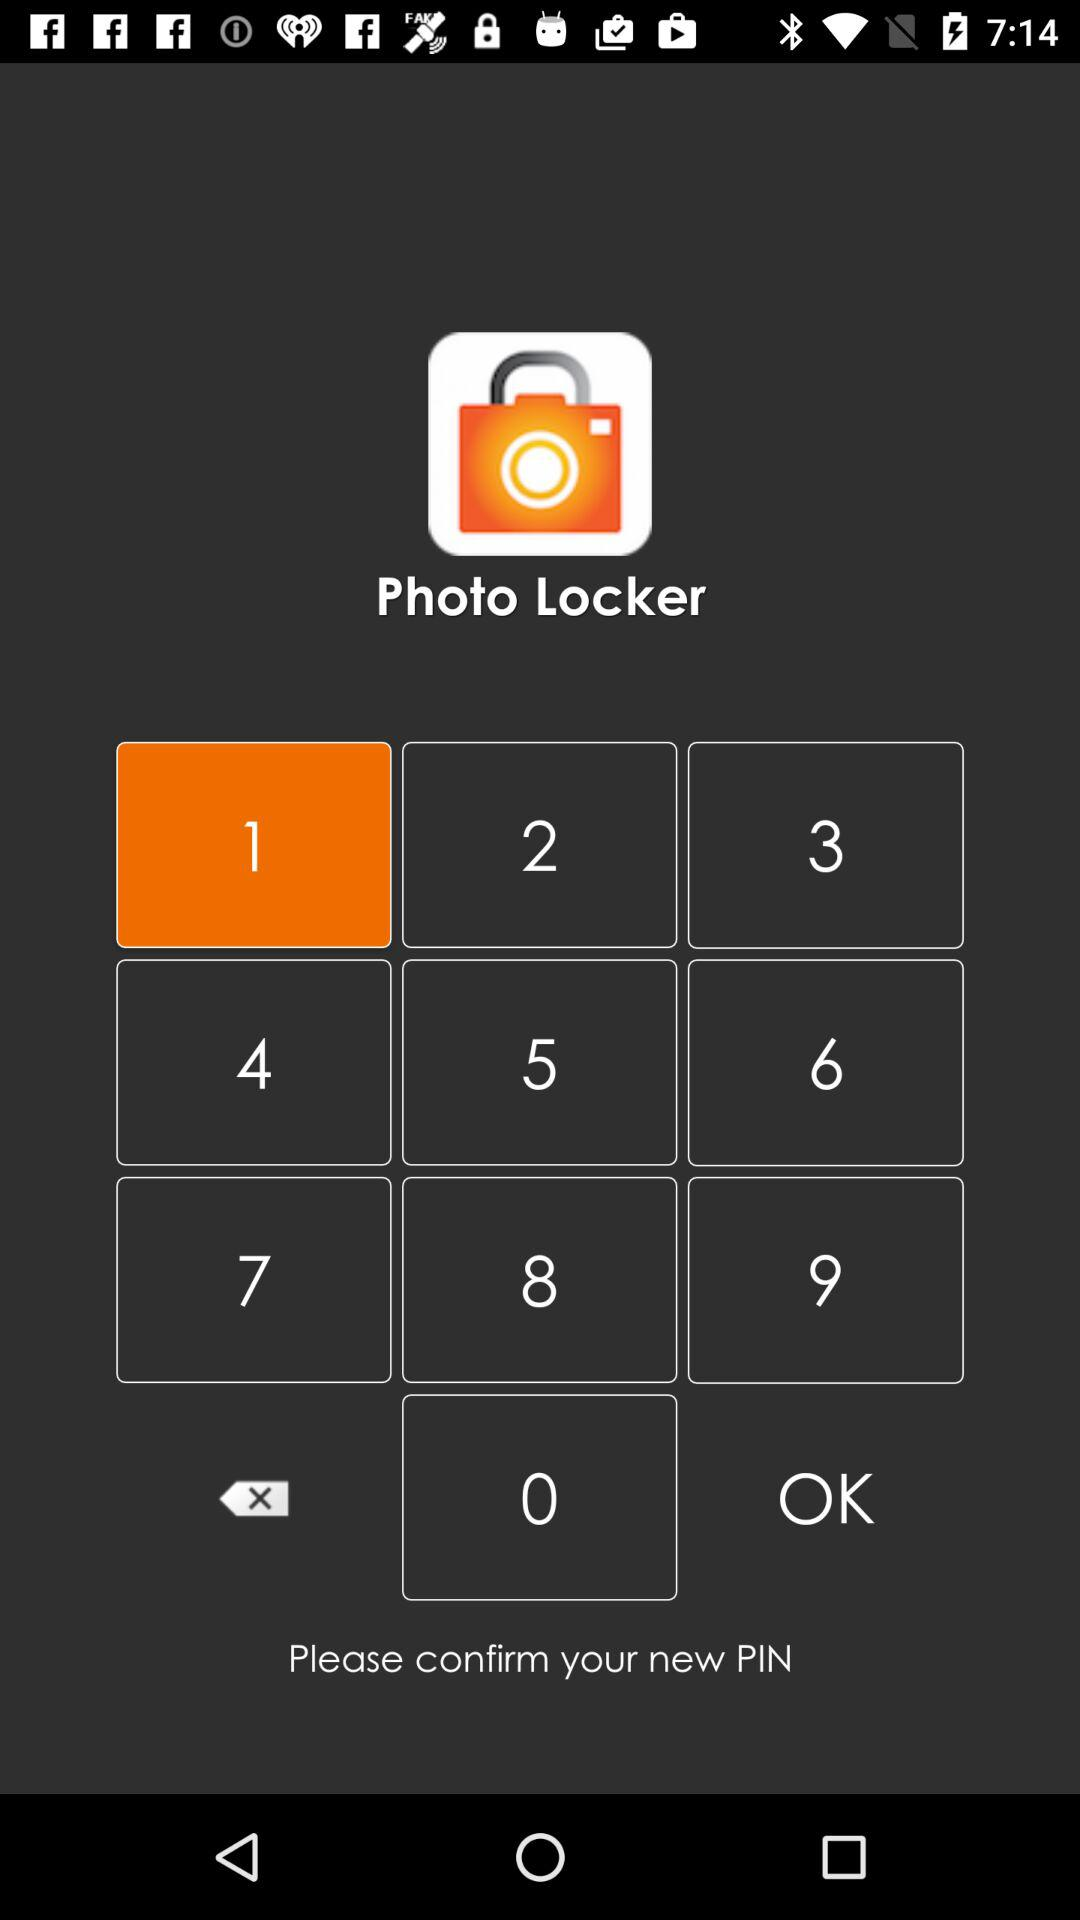What is the app name? The app name is "Photo Locker". 